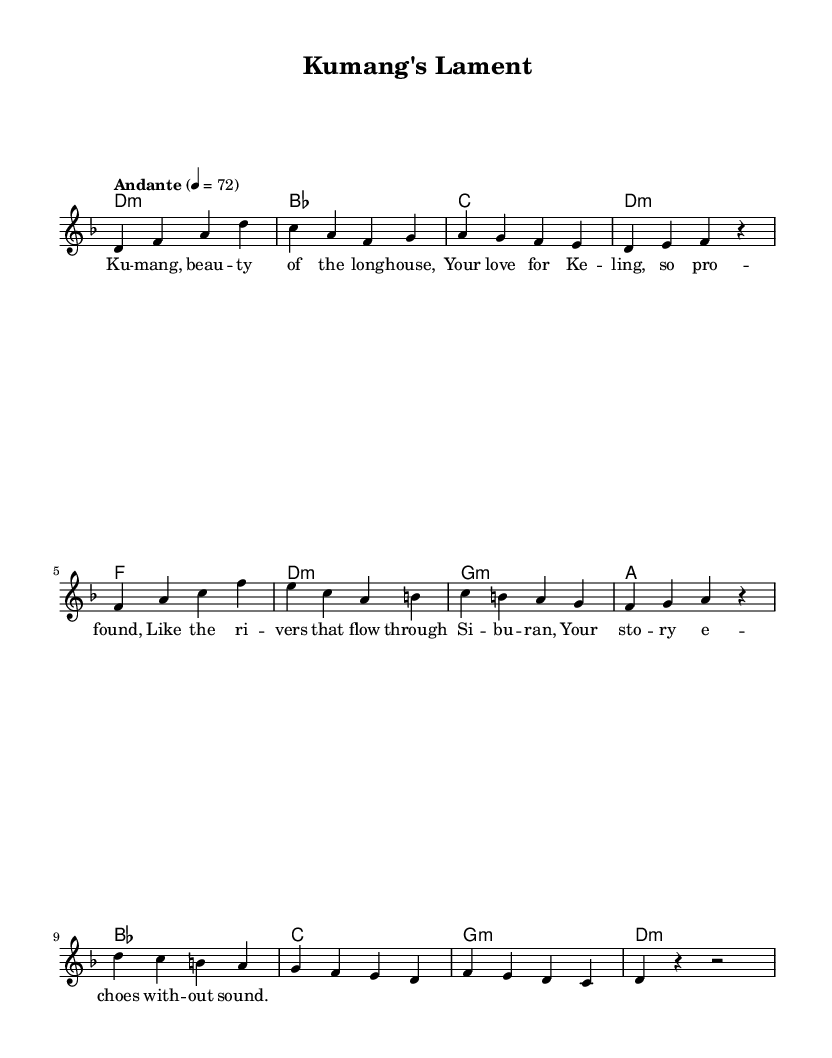What is the key signature of this music? The key signature is indicated at the beginning of the staff. In this case, it shows one flat (B flat), which means the piece is in D minor.
Answer: D minor What is the time signature of this piece? The time signature is indicated at the beginning of the score, shown as 4/4. This means there are four beats in each measure.
Answer: 4/4 What is the tempo marking of the piece? The tempo marking is located under the header and specifies the speed of the piece. It indicates "Andante" at 4 = 72, indicating a moderate walking pace.
Answer: Andante How many measures are in the melody? By counting the total bars in the melody section, there are a total of 12 measures (or bars) present.
Answer: 12 What type of harmony is predominantly used in the piece? The harmony sections include various chord modes, specifically, the piece mainly utilizes minor chords, such as D minor and G minor, indicating a romantic characteristic of melancholy.
Answer: Minor chords What is the title of the piece? The title of the piece is found in the header section at the top of the music sheet, where it is explicitly stated.
Answer: Kumang's Lament What theme does the lyrics convey? The lyrics describe a longing and deep connection, typical in romantic music, through imagery of rivers and beauty which ties into the Iban culture's appreciation of storytelling and nature.
Answer: Love and longing 